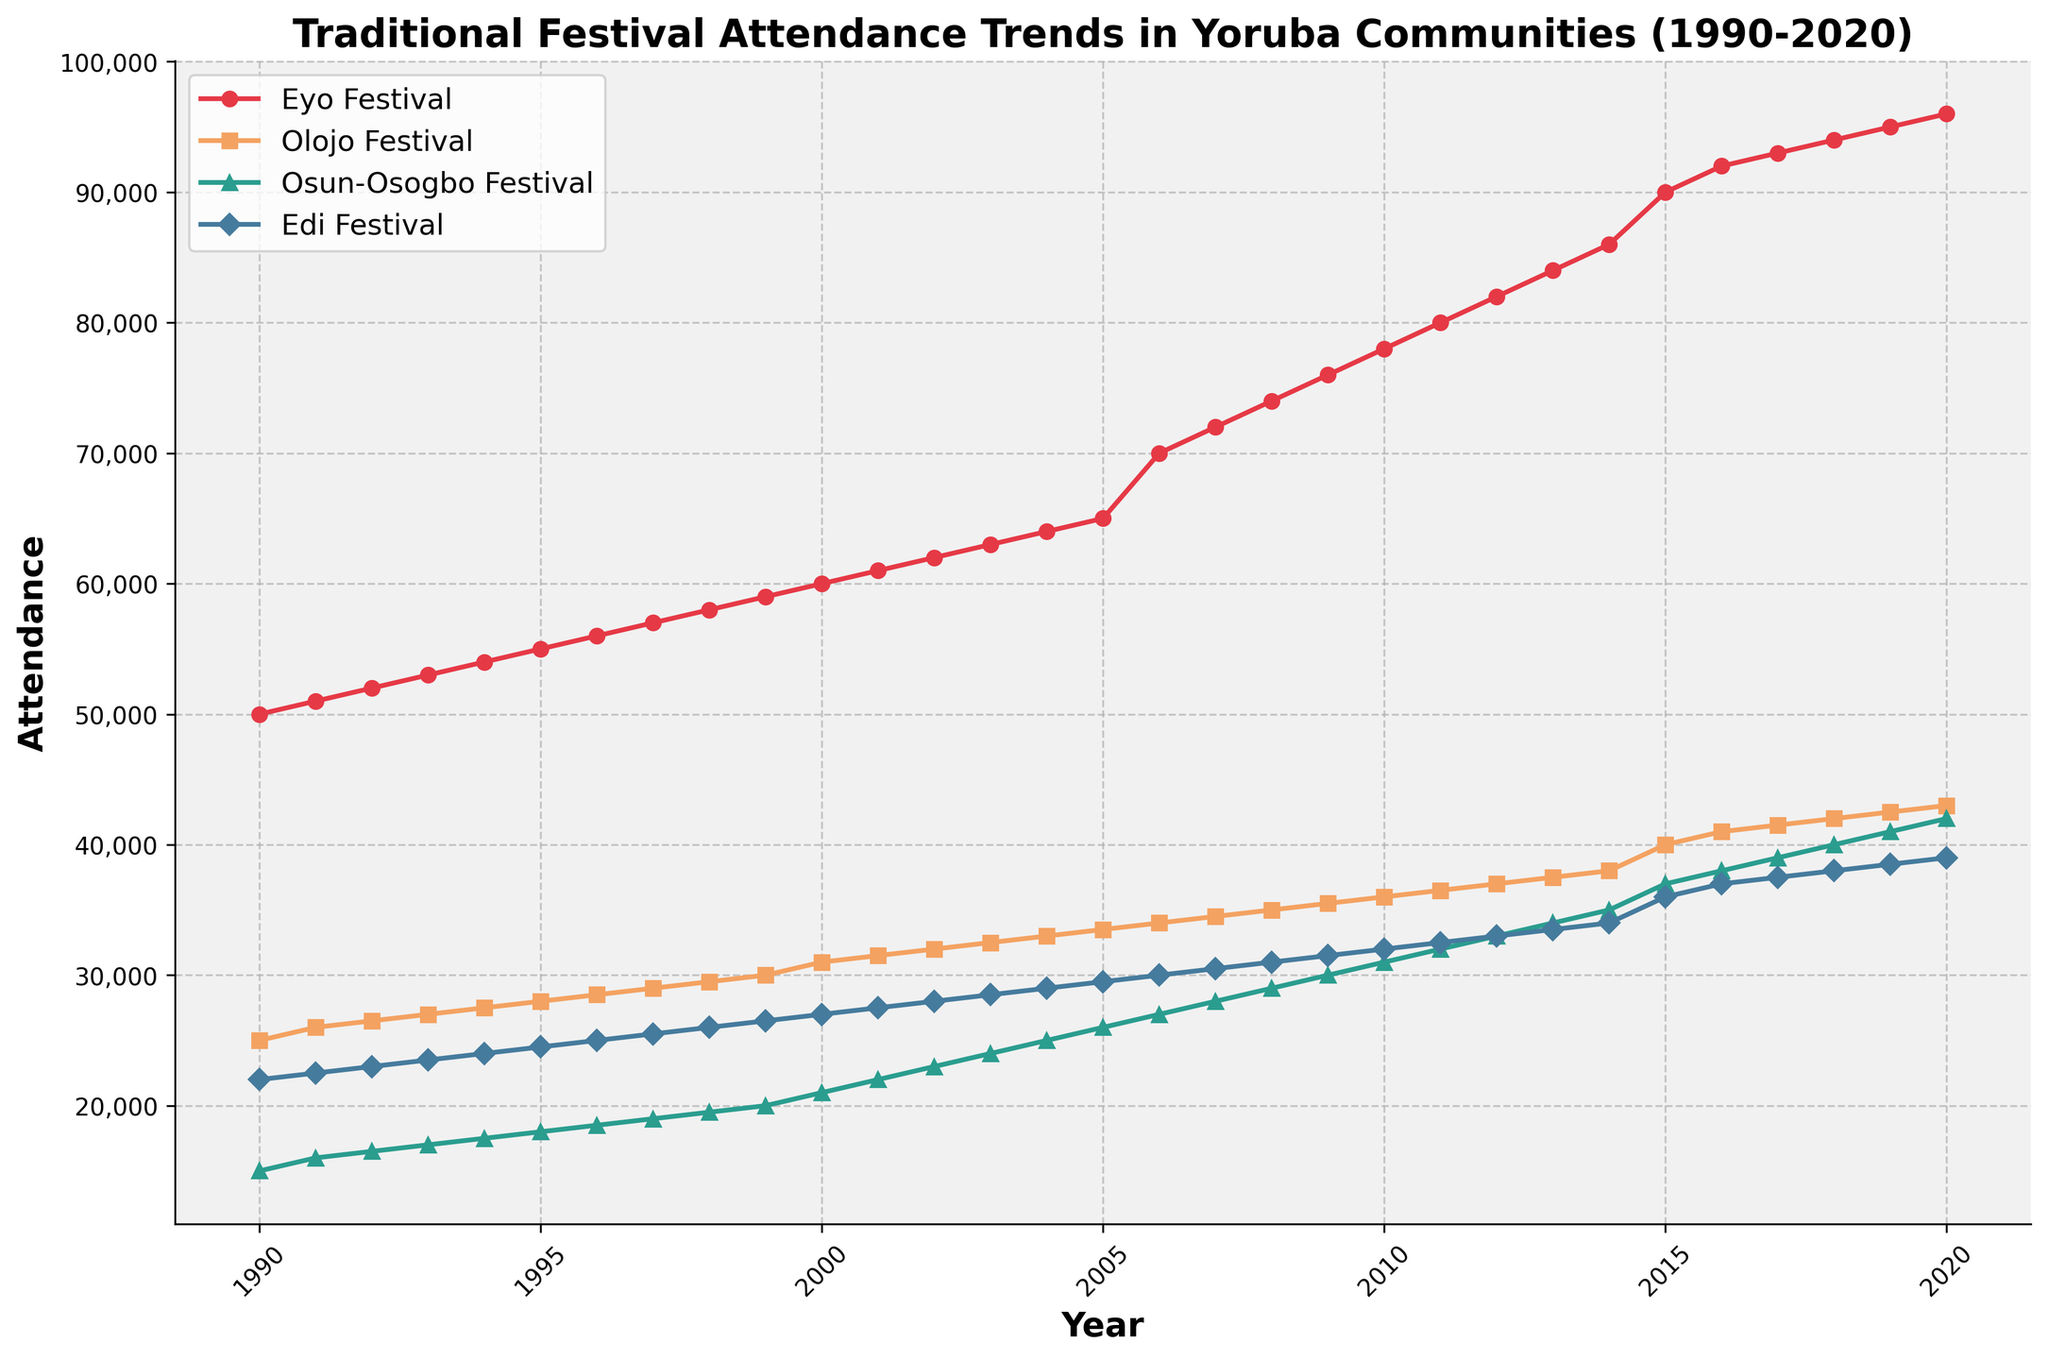What is the trend in Eyo Festival attendance from 1990 to 2020? The plot shows that Eyo Festival attendance has a visible upward trend from 1990 to 2020. The attendance starts at 50,000 in 1990 and increases steadily to 96,000 in 2020.
Answer: Upward trend How does the attendance of the Osun-Osogbo Festival in 2020 compare to that in 1990? By examining the plot, the Osun-Osogbo Festival attendance in 2020 is 42,000, while in 1990 it was 15,000. There is an increase in attendance over this period.
Answer: Increased Which festival had the highest attendance in 2010? By looking at the figure, in 2010, the Eyo Festival had the highest attendance among the plotted festivals, with 78,000 attendees.
Answer: Eyo Festival Calculate the average attendance of the Olojo Festival over the period 1990-2000. From 1990 to 2000, the respective attendance numbers for the Olojo Festival are 25,000, 26,000, 26,500, 27,000, 27,500, 28,000, 28,500, 29,000, 29,500, 30,000, and 31,000. The sum is 307,000. Dividing by 11 years gives an average of 27,909.09 attendees.
Answer: 27,909.09 What is the general trend of the Edi Festival attendance from 2000 to 2010? The Edi Festival attendance shows a steady increase from 27,000 in 2000 to 32,000 in 2010. Each year, there is a consistent rise in numbers.
Answer: Steady increase By how much did the attendance at the Olojo Festival grow between 1995 and 2020? The attendance of the Olojo Festival was 28,000 in 1995 and increased to 43,000 in 2020. The difference in attendance is 43,000 - 28,000 = 15,000.
Answer: 15,000 Which festival had the most significant attendance increase between 1990 and 2020? By comparing all festivals in the plot, the Eyo Festival had the most substantial attendance increase, from 50,000 in 1990 to 96,000 in 2020. The increase is 96,000 - 50,000 = 46,000.
Answer: Eyo Festival Are there any years where the attendance of the Osun-Osogbo Festival and the Olojo Festival intersect? Examining the plot, there are no years where the attendance lines of the Osun-Osogbo Festival and the Olojo Festival intersect.
Answer: No What can be inferred about the popularity of traditional festivals in Yoruba communities from 1990 to 2020? The overall trend across the four festivals shows a steady increase in attendance, indicating growing or sustained popularity of traditional festivals in Yoruba communities over the 30-year period.
Answer: Growing popularity 